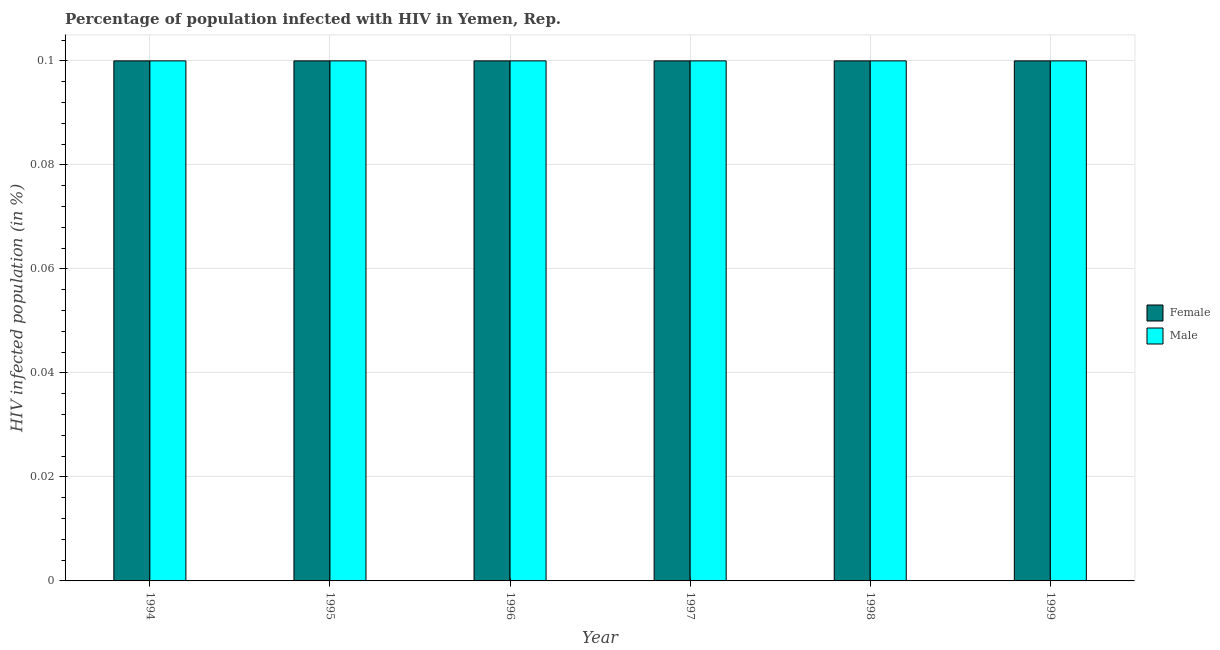How many different coloured bars are there?
Offer a terse response. 2. What is the label of the 2nd group of bars from the left?
Offer a very short reply. 1995. In how many cases, is the number of bars for a given year not equal to the number of legend labels?
Make the answer very short. 0. What is the percentage of females who are infected with hiv in 1996?
Offer a terse response. 0.1. Across all years, what is the maximum percentage of females who are infected with hiv?
Your answer should be very brief. 0.1. What is the difference between the percentage of females who are infected with hiv in 1994 and that in 1999?
Your answer should be compact. 0. What is the average percentage of males who are infected with hiv per year?
Your response must be concise. 0.1. In the year 1996, what is the difference between the percentage of males who are infected with hiv and percentage of females who are infected with hiv?
Provide a succinct answer. 0. In how many years, is the percentage of males who are infected with hiv greater than 0.092 %?
Keep it short and to the point. 6. Is the difference between the percentage of males who are infected with hiv in 1994 and 1996 greater than the difference between the percentage of females who are infected with hiv in 1994 and 1996?
Provide a succinct answer. No. In how many years, is the percentage of females who are infected with hiv greater than the average percentage of females who are infected with hiv taken over all years?
Provide a succinct answer. 6. What does the 2nd bar from the left in 1999 represents?
Your response must be concise. Male. What does the 2nd bar from the right in 1998 represents?
Provide a short and direct response. Female. How many bars are there?
Offer a terse response. 12. Are all the bars in the graph horizontal?
Your answer should be very brief. No. Are the values on the major ticks of Y-axis written in scientific E-notation?
Make the answer very short. No. Does the graph contain any zero values?
Offer a terse response. No. How are the legend labels stacked?
Offer a very short reply. Vertical. What is the title of the graph?
Ensure brevity in your answer.  Percentage of population infected with HIV in Yemen, Rep. What is the label or title of the X-axis?
Ensure brevity in your answer.  Year. What is the label or title of the Y-axis?
Make the answer very short. HIV infected population (in %). What is the HIV infected population (in %) in Female in 1994?
Your answer should be very brief. 0.1. What is the HIV infected population (in %) of Female in 1995?
Make the answer very short. 0.1. What is the HIV infected population (in %) in Male in 1996?
Give a very brief answer. 0.1. What is the HIV infected population (in %) in Female in 1997?
Your answer should be very brief. 0.1. What is the HIV infected population (in %) of Female in 1998?
Ensure brevity in your answer.  0.1. Across all years, what is the maximum HIV infected population (in %) in Male?
Offer a very short reply. 0.1. Across all years, what is the minimum HIV infected population (in %) of Female?
Ensure brevity in your answer.  0.1. Across all years, what is the minimum HIV infected population (in %) of Male?
Give a very brief answer. 0.1. What is the difference between the HIV infected population (in %) in Female in 1994 and that in 1995?
Offer a terse response. 0. What is the difference between the HIV infected population (in %) in Female in 1994 and that in 1996?
Provide a succinct answer. 0. What is the difference between the HIV infected population (in %) of Male in 1994 and that in 1996?
Offer a very short reply. 0. What is the difference between the HIV infected population (in %) in Male in 1994 and that in 1997?
Your answer should be very brief. 0. What is the difference between the HIV infected population (in %) of Female in 1994 and that in 1998?
Offer a terse response. 0. What is the difference between the HIV infected population (in %) in Male in 1994 and that in 1998?
Keep it short and to the point. 0. What is the difference between the HIV infected population (in %) in Female in 1994 and that in 1999?
Your response must be concise. 0. What is the difference between the HIV infected population (in %) in Female in 1995 and that in 1996?
Make the answer very short. 0. What is the difference between the HIV infected population (in %) in Male in 1995 and that in 1996?
Keep it short and to the point. 0. What is the difference between the HIV infected population (in %) in Female in 1995 and that in 1997?
Provide a succinct answer. 0. What is the difference between the HIV infected population (in %) of Male in 1995 and that in 1997?
Offer a terse response. 0. What is the difference between the HIV infected population (in %) in Female in 1995 and that in 1998?
Offer a terse response. 0. What is the difference between the HIV infected population (in %) of Male in 1995 and that in 1998?
Your answer should be very brief. 0. What is the difference between the HIV infected population (in %) of Female in 1995 and that in 1999?
Keep it short and to the point. 0. What is the difference between the HIV infected population (in %) of Female in 1996 and that in 1997?
Your answer should be very brief. 0. What is the difference between the HIV infected population (in %) of Male in 1996 and that in 1997?
Ensure brevity in your answer.  0. What is the difference between the HIV infected population (in %) of Female in 1996 and that in 1998?
Provide a succinct answer. 0. What is the difference between the HIV infected population (in %) in Male in 1996 and that in 1998?
Make the answer very short. 0. What is the difference between the HIV infected population (in %) of Female in 1996 and that in 1999?
Provide a succinct answer. 0. What is the difference between the HIV infected population (in %) of Male in 1996 and that in 1999?
Provide a short and direct response. 0. What is the difference between the HIV infected population (in %) of Female in 1997 and that in 1998?
Keep it short and to the point. 0. What is the difference between the HIV infected population (in %) of Female in 1997 and that in 1999?
Offer a very short reply. 0. What is the difference between the HIV infected population (in %) in Male in 1998 and that in 1999?
Keep it short and to the point. 0. What is the difference between the HIV infected population (in %) of Female in 1994 and the HIV infected population (in %) of Male in 1997?
Your answer should be very brief. 0. What is the difference between the HIV infected population (in %) in Female in 1994 and the HIV infected population (in %) in Male in 1998?
Provide a succinct answer. 0. What is the difference between the HIV infected population (in %) of Female in 1995 and the HIV infected population (in %) of Male in 1996?
Provide a succinct answer. 0. What is the difference between the HIV infected population (in %) of Female in 1995 and the HIV infected population (in %) of Male in 1998?
Offer a terse response. 0. What is the difference between the HIV infected population (in %) of Female in 1995 and the HIV infected population (in %) of Male in 1999?
Offer a very short reply. 0. What is the difference between the HIV infected population (in %) of Female in 1996 and the HIV infected population (in %) of Male in 1998?
Give a very brief answer. 0. What is the difference between the HIV infected population (in %) in Female in 1997 and the HIV infected population (in %) in Male in 1998?
Your answer should be compact. 0. What is the average HIV infected population (in %) in Female per year?
Provide a succinct answer. 0.1. What is the average HIV infected population (in %) in Male per year?
Ensure brevity in your answer.  0.1. In the year 1996, what is the difference between the HIV infected population (in %) of Female and HIV infected population (in %) of Male?
Keep it short and to the point. 0. In the year 1999, what is the difference between the HIV infected population (in %) of Female and HIV infected population (in %) of Male?
Ensure brevity in your answer.  0. What is the ratio of the HIV infected population (in %) in Male in 1994 to that in 1995?
Keep it short and to the point. 1. What is the ratio of the HIV infected population (in %) of Female in 1994 to that in 1996?
Ensure brevity in your answer.  1. What is the ratio of the HIV infected population (in %) in Male in 1994 to that in 1996?
Your response must be concise. 1. What is the ratio of the HIV infected population (in %) in Female in 1994 to that in 1997?
Offer a very short reply. 1. What is the ratio of the HIV infected population (in %) in Male in 1994 to that in 1997?
Offer a terse response. 1. What is the ratio of the HIV infected population (in %) of Male in 1994 to that in 1998?
Ensure brevity in your answer.  1. What is the ratio of the HIV infected population (in %) in Female in 1995 to that in 1996?
Offer a very short reply. 1. What is the ratio of the HIV infected population (in %) in Male in 1995 to that in 1996?
Provide a succinct answer. 1. What is the ratio of the HIV infected population (in %) in Female in 1995 to that in 1997?
Your answer should be compact. 1. What is the ratio of the HIV infected population (in %) in Male in 1995 to that in 1997?
Offer a very short reply. 1. What is the ratio of the HIV infected population (in %) in Male in 1995 to that in 1999?
Provide a short and direct response. 1. What is the ratio of the HIV infected population (in %) in Female in 1996 to that in 1997?
Provide a short and direct response. 1. What is the ratio of the HIV infected population (in %) of Male in 1996 to that in 1997?
Provide a succinct answer. 1. What is the ratio of the HIV infected population (in %) in Female in 1996 to that in 1998?
Make the answer very short. 1. What is the ratio of the HIV infected population (in %) in Male in 1996 to that in 1998?
Offer a very short reply. 1. What is the ratio of the HIV infected population (in %) of Male in 1996 to that in 1999?
Your answer should be very brief. 1. What is the ratio of the HIV infected population (in %) of Female in 1998 to that in 1999?
Your answer should be compact. 1. What is the difference between the highest and the second highest HIV infected population (in %) in Male?
Offer a terse response. 0. What is the difference between the highest and the lowest HIV infected population (in %) of Female?
Your answer should be very brief. 0. What is the difference between the highest and the lowest HIV infected population (in %) of Male?
Keep it short and to the point. 0. 